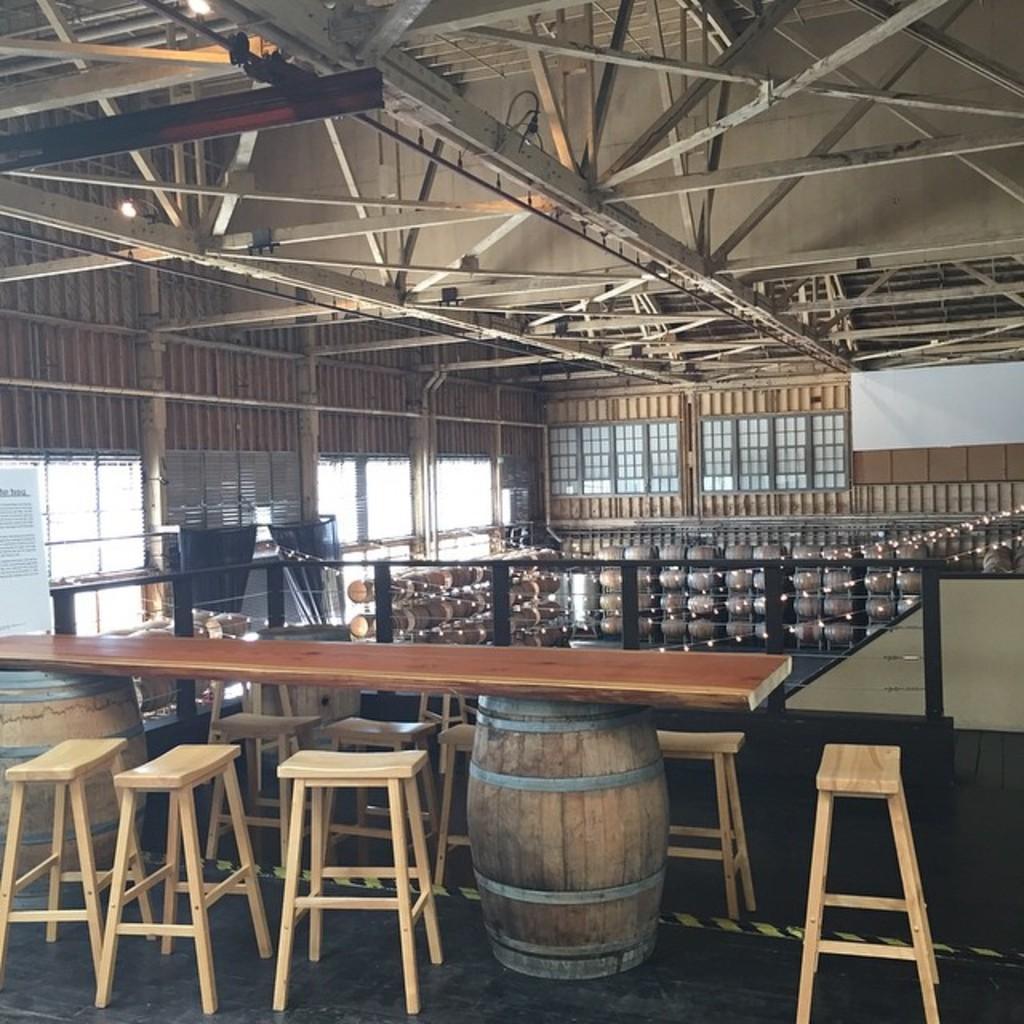In one or two sentences, can you explain what this image depicts? This is an inside view of a shed. At the bottom there is a wooden plank placed on two drums. There are many empty stools. On the right side there is a table. In the background there are many objects and few lines are attached to the railing. On the left side there are few windows. In the background there is a board attached to the wall and there are few metal frames. At the top of the image I can see few metal rods. 